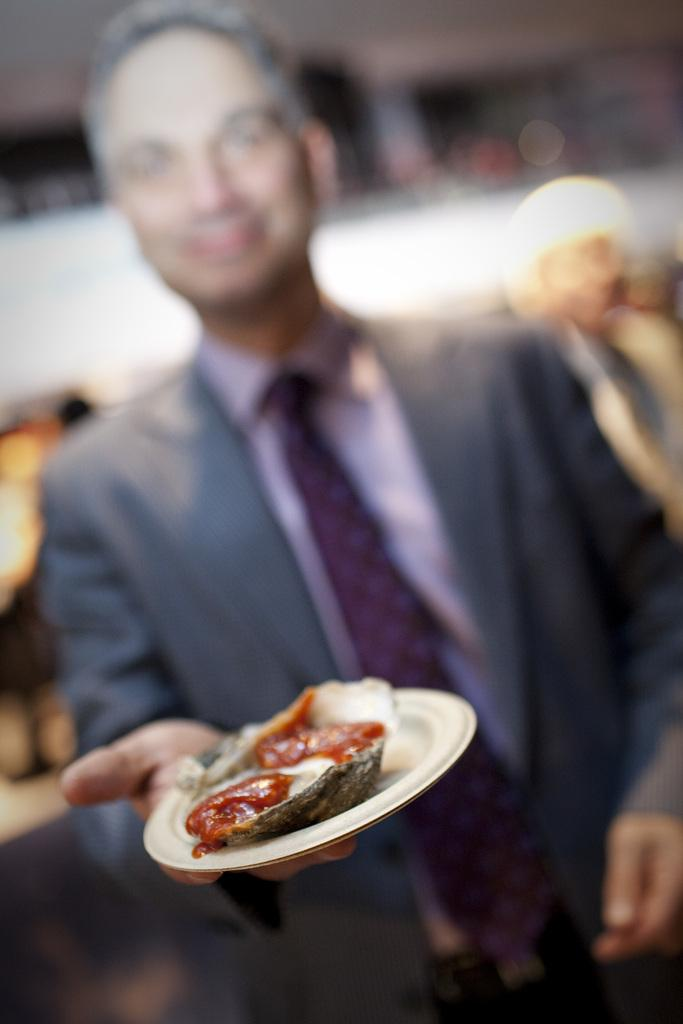What is present in the image? There is a man in the image. What is the man wearing? The man is wearing clothes. What is the man holding in his hand? The man is holding a plate in his hand. What color is the plate? The plate is white in color. What can be found on the plate? There is a food item on the plate. How would you describe the background of the image? The background of the image is blurred. What type of glove is the man wearing in the image? The man is not wearing a glove in the image; he is wearing clothes. Can you compare the man's outfit to another person's outfit in the image? There is no other person in the image to compare the man's outfit to. 